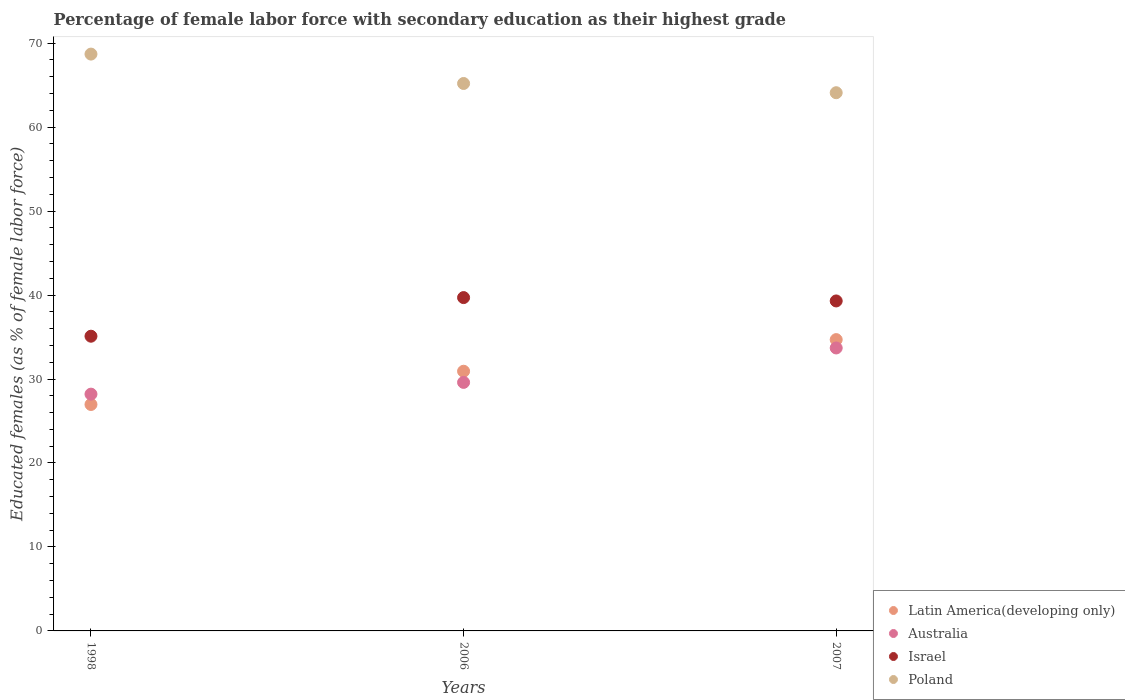Is the number of dotlines equal to the number of legend labels?
Provide a succinct answer. Yes. What is the percentage of female labor force with secondary education in Poland in 2007?
Your answer should be very brief. 64.1. Across all years, what is the maximum percentage of female labor force with secondary education in Poland?
Your answer should be compact. 68.7. Across all years, what is the minimum percentage of female labor force with secondary education in Israel?
Provide a succinct answer. 35.1. In which year was the percentage of female labor force with secondary education in Poland minimum?
Provide a succinct answer. 2007. What is the total percentage of female labor force with secondary education in Latin America(developing only) in the graph?
Provide a succinct answer. 92.59. What is the difference between the percentage of female labor force with secondary education in Latin America(developing only) in 1998 and that in 2007?
Ensure brevity in your answer.  -7.73. What is the difference between the percentage of female labor force with secondary education in Israel in 2006 and the percentage of female labor force with secondary education in Australia in 2007?
Ensure brevity in your answer.  6. What is the average percentage of female labor force with secondary education in Latin America(developing only) per year?
Provide a succinct answer. 30.86. In the year 2007, what is the difference between the percentage of female labor force with secondary education in Israel and percentage of female labor force with secondary education in Australia?
Offer a very short reply. 5.6. In how many years, is the percentage of female labor force with secondary education in Israel greater than 2 %?
Give a very brief answer. 3. What is the ratio of the percentage of female labor force with secondary education in Poland in 2006 to that in 2007?
Your answer should be compact. 1.02. Is the difference between the percentage of female labor force with secondary education in Israel in 1998 and 2007 greater than the difference between the percentage of female labor force with secondary education in Australia in 1998 and 2007?
Provide a short and direct response. Yes. What is the difference between the highest and the second highest percentage of female labor force with secondary education in Australia?
Your answer should be very brief. 4.1. What is the difference between the highest and the lowest percentage of female labor force with secondary education in Australia?
Provide a short and direct response. 5.5. In how many years, is the percentage of female labor force with secondary education in Australia greater than the average percentage of female labor force with secondary education in Australia taken over all years?
Your response must be concise. 1. Is the sum of the percentage of female labor force with secondary education in Israel in 1998 and 2007 greater than the maximum percentage of female labor force with secondary education in Poland across all years?
Provide a short and direct response. Yes. Is it the case that in every year, the sum of the percentage of female labor force with secondary education in Poland and percentage of female labor force with secondary education in Israel  is greater than the sum of percentage of female labor force with secondary education in Latin America(developing only) and percentage of female labor force with secondary education in Australia?
Provide a succinct answer. Yes. Is the percentage of female labor force with secondary education in Israel strictly greater than the percentage of female labor force with secondary education in Poland over the years?
Provide a short and direct response. No. Is the percentage of female labor force with secondary education in Latin America(developing only) strictly less than the percentage of female labor force with secondary education in Australia over the years?
Offer a very short reply. No. How many dotlines are there?
Your answer should be very brief. 4. How many years are there in the graph?
Ensure brevity in your answer.  3. What is the difference between two consecutive major ticks on the Y-axis?
Provide a succinct answer. 10. Does the graph contain grids?
Provide a short and direct response. No. Where does the legend appear in the graph?
Give a very brief answer. Bottom right. What is the title of the graph?
Offer a terse response. Percentage of female labor force with secondary education as their highest grade. Does "Cote d'Ivoire" appear as one of the legend labels in the graph?
Your answer should be very brief. No. What is the label or title of the Y-axis?
Provide a short and direct response. Educated females (as % of female labor force). What is the Educated females (as % of female labor force) in Latin America(developing only) in 1998?
Give a very brief answer. 26.97. What is the Educated females (as % of female labor force) in Australia in 1998?
Your answer should be compact. 28.2. What is the Educated females (as % of female labor force) in Israel in 1998?
Provide a succinct answer. 35.1. What is the Educated females (as % of female labor force) of Poland in 1998?
Keep it short and to the point. 68.7. What is the Educated females (as % of female labor force) in Latin America(developing only) in 2006?
Offer a terse response. 30.93. What is the Educated females (as % of female labor force) in Australia in 2006?
Offer a terse response. 29.6. What is the Educated females (as % of female labor force) of Israel in 2006?
Offer a very short reply. 39.7. What is the Educated females (as % of female labor force) of Poland in 2006?
Keep it short and to the point. 65.2. What is the Educated females (as % of female labor force) in Latin America(developing only) in 2007?
Provide a short and direct response. 34.69. What is the Educated females (as % of female labor force) in Australia in 2007?
Offer a terse response. 33.7. What is the Educated females (as % of female labor force) in Israel in 2007?
Ensure brevity in your answer.  39.3. What is the Educated females (as % of female labor force) in Poland in 2007?
Ensure brevity in your answer.  64.1. Across all years, what is the maximum Educated females (as % of female labor force) of Latin America(developing only)?
Provide a succinct answer. 34.69. Across all years, what is the maximum Educated females (as % of female labor force) of Australia?
Offer a very short reply. 33.7. Across all years, what is the maximum Educated females (as % of female labor force) in Israel?
Offer a terse response. 39.7. Across all years, what is the maximum Educated females (as % of female labor force) of Poland?
Provide a succinct answer. 68.7. Across all years, what is the minimum Educated females (as % of female labor force) of Latin America(developing only)?
Offer a very short reply. 26.97. Across all years, what is the minimum Educated females (as % of female labor force) in Australia?
Offer a terse response. 28.2. Across all years, what is the minimum Educated females (as % of female labor force) of Israel?
Offer a very short reply. 35.1. Across all years, what is the minimum Educated females (as % of female labor force) of Poland?
Ensure brevity in your answer.  64.1. What is the total Educated females (as % of female labor force) of Latin America(developing only) in the graph?
Your answer should be compact. 92.59. What is the total Educated females (as % of female labor force) of Australia in the graph?
Give a very brief answer. 91.5. What is the total Educated females (as % of female labor force) of Israel in the graph?
Ensure brevity in your answer.  114.1. What is the total Educated females (as % of female labor force) of Poland in the graph?
Your response must be concise. 198. What is the difference between the Educated females (as % of female labor force) in Latin America(developing only) in 1998 and that in 2006?
Make the answer very short. -3.96. What is the difference between the Educated females (as % of female labor force) in Poland in 1998 and that in 2006?
Keep it short and to the point. 3.5. What is the difference between the Educated females (as % of female labor force) of Latin America(developing only) in 1998 and that in 2007?
Keep it short and to the point. -7.73. What is the difference between the Educated females (as % of female labor force) of Australia in 1998 and that in 2007?
Provide a succinct answer. -5.5. What is the difference between the Educated females (as % of female labor force) in Israel in 1998 and that in 2007?
Your response must be concise. -4.2. What is the difference between the Educated females (as % of female labor force) in Poland in 1998 and that in 2007?
Give a very brief answer. 4.6. What is the difference between the Educated females (as % of female labor force) of Latin America(developing only) in 2006 and that in 2007?
Offer a very short reply. -3.77. What is the difference between the Educated females (as % of female labor force) in Israel in 2006 and that in 2007?
Offer a terse response. 0.4. What is the difference between the Educated females (as % of female labor force) of Latin America(developing only) in 1998 and the Educated females (as % of female labor force) of Australia in 2006?
Your response must be concise. -2.63. What is the difference between the Educated females (as % of female labor force) in Latin America(developing only) in 1998 and the Educated females (as % of female labor force) in Israel in 2006?
Your answer should be compact. -12.73. What is the difference between the Educated females (as % of female labor force) in Latin America(developing only) in 1998 and the Educated females (as % of female labor force) in Poland in 2006?
Your response must be concise. -38.23. What is the difference between the Educated females (as % of female labor force) in Australia in 1998 and the Educated females (as % of female labor force) in Israel in 2006?
Ensure brevity in your answer.  -11.5. What is the difference between the Educated females (as % of female labor force) in Australia in 1998 and the Educated females (as % of female labor force) in Poland in 2006?
Ensure brevity in your answer.  -37. What is the difference between the Educated females (as % of female labor force) of Israel in 1998 and the Educated females (as % of female labor force) of Poland in 2006?
Your response must be concise. -30.1. What is the difference between the Educated females (as % of female labor force) of Latin America(developing only) in 1998 and the Educated females (as % of female labor force) of Australia in 2007?
Your response must be concise. -6.73. What is the difference between the Educated females (as % of female labor force) in Latin America(developing only) in 1998 and the Educated females (as % of female labor force) in Israel in 2007?
Offer a very short reply. -12.33. What is the difference between the Educated females (as % of female labor force) of Latin America(developing only) in 1998 and the Educated females (as % of female labor force) of Poland in 2007?
Your response must be concise. -37.13. What is the difference between the Educated females (as % of female labor force) in Australia in 1998 and the Educated females (as % of female labor force) in Israel in 2007?
Your response must be concise. -11.1. What is the difference between the Educated females (as % of female labor force) of Australia in 1998 and the Educated females (as % of female labor force) of Poland in 2007?
Your answer should be very brief. -35.9. What is the difference between the Educated females (as % of female labor force) in Israel in 1998 and the Educated females (as % of female labor force) in Poland in 2007?
Provide a succinct answer. -29. What is the difference between the Educated females (as % of female labor force) of Latin America(developing only) in 2006 and the Educated females (as % of female labor force) of Australia in 2007?
Provide a short and direct response. -2.77. What is the difference between the Educated females (as % of female labor force) in Latin America(developing only) in 2006 and the Educated females (as % of female labor force) in Israel in 2007?
Offer a very short reply. -8.37. What is the difference between the Educated females (as % of female labor force) in Latin America(developing only) in 2006 and the Educated females (as % of female labor force) in Poland in 2007?
Offer a very short reply. -33.17. What is the difference between the Educated females (as % of female labor force) in Australia in 2006 and the Educated females (as % of female labor force) in Poland in 2007?
Keep it short and to the point. -34.5. What is the difference between the Educated females (as % of female labor force) in Israel in 2006 and the Educated females (as % of female labor force) in Poland in 2007?
Keep it short and to the point. -24.4. What is the average Educated females (as % of female labor force) in Latin America(developing only) per year?
Give a very brief answer. 30.86. What is the average Educated females (as % of female labor force) of Australia per year?
Make the answer very short. 30.5. What is the average Educated females (as % of female labor force) of Israel per year?
Make the answer very short. 38.03. What is the average Educated females (as % of female labor force) in Poland per year?
Offer a very short reply. 66. In the year 1998, what is the difference between the Educated females (as % of female labor force) of Latin America(developing only) and Educated females (as % of female labor force) of Australia?
Your answer should be compact. -1.23. In the year 1998, what is the difference between the Educated females (as % of female labor force) of Latin America(developing only) and Educated females (as % of female labor force) of Israel?
Offer a terse response. -8.13. In the year 1998, what is the difference between the Educated females (as % of female labor force) of Latin America(developing only) and Educated females (as % of female labor force) of Poland?
Give a very brief answer. -41.73. In the year 1998, what is the difference between the Educated females (as % of female labor force) of Australia and Educated females (as % of female labor force) of Israel?
Offer a terse response. -6.9. In the year 1998, what is the difference between the Educated females (as % of female labor force) in Australia and Educated females (as % of female labor force) in Poland?
Provide a succinct answer. -40.5. In the year 1998, what is the difference between the Educated females (as % of female labor force) in Israel and Educated females (as % of female labor force) in Poland?
Make the answer very short. -33.6. In the year 2006, what is the difference between the Educated females (as % of female labor force) in Latin America(developing only) and Educated females (as % of female labor force) in Australia?
Give a very brief answer. 1.33. In the year 2006, what is the difference between the Educated females (as % of female labor force) of Latin America(developing only) and Educated females (as % of female labor force) of Israel?
Offer a terse response. -8.77. In the year 2006, what is the difference between the Educated females (as % of female labor force) in Latin America(developing only) and Educated females (as % of female labor force) in Poland?
Give a very brief answer. -34.27. In the year 2006, what is the difference between the Educated females (as % of female labor force) of Australia and Educated females (as % of female labor force) of Poland?
Make the answer very short. -35.6. In the year 2006, what is the difference between the Educated females (as % of female labor force) of Israel and Educated females (as % of female labor force) of Poland?
Provide a short and direct response. -25.5. In the year 2007, what is the difference between the Educated females (as % of female labor force) of Latin America(developing only) and Educated females (as % of female labor force) of Israel?
Offer a terse response. -4.61. In the year 2007, what is the difference between the Educated females (as % of female labor force) in Latin America(developing only) and Educated females (as % of female labor force) in Poland?
Your answer should be very brief. -29.41. In the year 2007, what is the difference between the Educated females (as % of female labor force) of Australia and Educated females (as % of female labor force) of Poland?
Make the answer very short. -30.4. In the year 2007, what is the difference between the Educated females (as % of female labor force) in Israel and Educated females (as % of female labor force) in Poland?
Your answer should be compact. -24.8. What is the ratio of the Educated females (as % of female labor force) in Latin America(developing only) in 1998 to that in 2006?
Provide a succinct answer. 0.87. What is the ratio of the Educated females (as % of female labor force) of Australia in 1998 to that in 2006?
Offer a terse response. 0.95. What is the ratio of the Educated females (as % of female labor force) of Israel in 1998 to that in 2006?
Ensure brevity in your answer.  0.88. What is the ratio of the Educated females (as % of female labor force) in Poland in 1998 to that in 2006?
Your response must be concise. 1.05. What is the ratio of the Educated females (as % of female labor force) of Latin America(developing only) in 1998 to that in 2007?
Offer a very short reply. 0.78. What is the ratio of the Educated females (as % of female labor force) of Australia in 1998 to that in 2007?
Offer a very short reply. 0.84. What is the ratio of the Educated females (as % of female labor force) in Israel in 1998 to that in 2007?
Ensure brevity in your answer.  0.89. What is the ratio of the Educated females (as % of female labor force) of Poland in 1998 to that in 2007?
Offer a very short reply. 1.07. What is the ratio of the Educated females (as % of female labor force) in Latin America(developing only) in 2006 to that in 2007?
Offer a very short reply. 0.89. What is the ratio of the Educated females (as % of female labor force) of Australia in 2006 to that in 2007?
Your answer should be very brief. 0.88. What is the ratio of the Educated females (as % of female labor force) in Israel in 2006 to that in 2007?
Offer a very short reply. 1.01. What is the ratio of the Educated females (as % of female labor force) in Poland in 2006 to that in 2007?
Provide a short and direct response. 1.02. What is the difference between the highest and the second highest Educated females (as % of female labor force) of Latin America(developing only)?
Give a very brief answer. 3.77. What is the difference between the highest and the second highest Educated females (as % of female labor force) in Australia?
Offer a very short reply. 4.1. What is the difference between the highest and the second highest Educated females (as % of female labor force) of Poland?
Your answer should be compact. 3.5. What is the difference between the highest and the lowest Educated females (as % of female labor force) in Latin America(developing only)?
Your answer should be very brief. 7.73. What is the difference between the highest and the lowest Educated females (as % of female labor force) in Poland?
Provide a succinct answer. 4.6. 